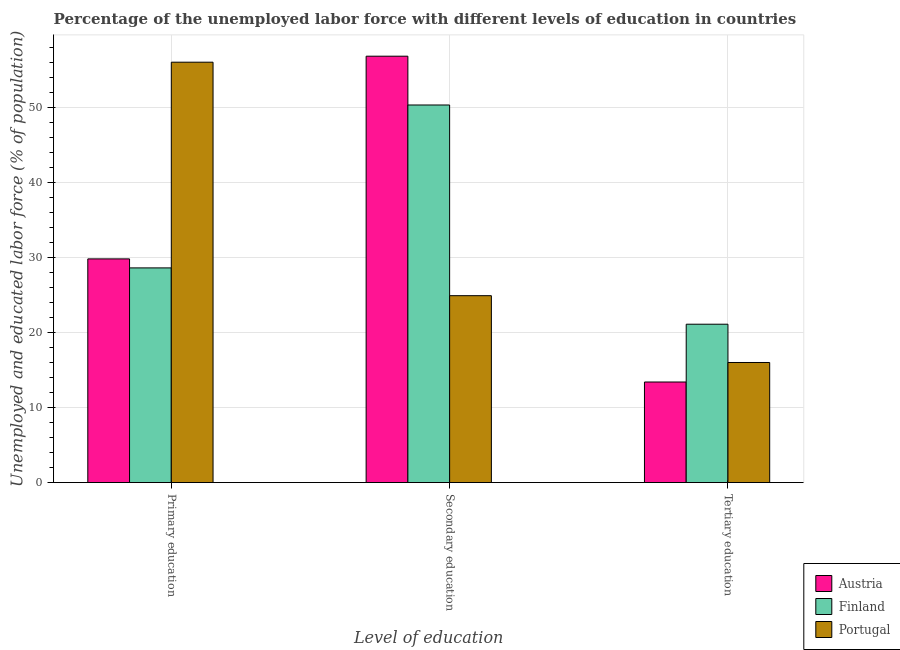How many different coloured bars are there?
Offer a terse response. 3. Are the number of bars on each tick of the X-axis equal?
Give a very brief answer. Yes. What is the label of the 1st group of bars from the left?
Your response must be concise. Primary education. What is the percentage of labor force who received secondary education in Austria?
Your answer should be very brief. 56.8. Across all countries, what is the maximum percentage of labor force who received tertiary education?
Provide a short and direct response. 21.1. Across all countries, what is the minimum percentage of labor force who received secondary education?
Your answer should be compact. 24.9. In which country was the percentage of labor force who received tertiary education maximum?
Make the answer very short. Finland. What is the total percentage of labor force who received secondary education in the graph?
Provide a succinct answer. 132. What is the difference between the percentage of labor force who received tertiary education in Finland and that in Portugal?
Your response must be concise. 5.1. What is the difference between the percentage of labor force who received secondary education in Finland and the percentage of labor force who received tertiary education in Austria?
Provide a short and direct response. 36.9. What is the average percentage of labor force who received primary education per country?
Your answer should be very brief. 38.13. What is the difference between the percentage of labor force who received secondary education and percentage of labor force who received primary education in Austria?
Keep it short and to the point. 27. In how many countries, is the percentage of labor force who received tertiary education greater than 28 %?
Your response must be concise. 0. What is the ratio of the percentage of labor force who received secondary education in Portugal to that in Austria?
Offer a terse response. 0.44. Is the difference between the percentage of labor force who received primary education in Finland and Portugal greater than the difference between the percentage of labor force who received secondary education in Finland and Portugal?
Provide a short and direct response. No. What is the difference between the highest and the lowest percentage of labor force who received tertiary education?
Provide a succinct answer. 7.7. In how many countries, is the percentage of labor force who received tertiary education greater than the average percentage of labor force who received tertiary education taken over all countries?
Give a very brief answer. 1. Is the sum of the percentage of labor force who received tertiary education in Portugal and Austria greater than the maximum percentage of labor force who received primary education across all countries?
Give a very brief answer. No. What does the 3rd bar from the left in Primary education represents?
Offer a terse response. Portugal. What does the 1st bar from the right in Primary education represents?
Offer a very short reply. Portugal. How many countries are there in the graph?
Your answer should be compact. 3. Does the graph contain any zero values?
Offer a very short reply. No. Where does the legend appear in the graph?
Make the answer very short. Bottom right. What is the title of the graph?
Make the answer very short. Percentage of the unemployed labor force with different levels of education in countries. Does "Vietnam" appear as one of the legend labels in the graph?
Ensure brevity in your answer.  No. What is the label or title of the X-axis?
Your response must be concise. Level of education. What is the label or title of the Y-axis?
Your answer should be compact. Unemployed and educated labor force (% of population). What is the Unemployed and educated labor force (% of population) of Austria in Primary education?
Offer a terse response. 29.8. What is the Unemployed and educated labor force (% of population) in Finland in Primary education?
Offer a very short reply. 28.6. What is the Unemployed and educated labor force (% of population) in Portugal in Primary education?
Your answer should be compact. 56. What is the Unemployed and educated labor force (% of population) in Austria in Secondary education?
Make the answer very short. 56.8. What is the Unemployed and educated labor force (% of population) in Finland in Secondary education?
Provide a short and direct response. 50.3. What is the Unemployed and educated labor force (% of population) in Portugal in Secondary education?
Offer a very short reply. 24.9. What is the Unemployed and educated labor force (% of population) in Austria in Tertiary education?
Offer a very short reply. 13.4. What is the Unemployed and educated labor force (% of population) of Finland in Tertiary education?
Provide a succinct answer. 21.1. What is the Unemployed and educated labor force (% of population) of Portugal in Tertiary education?
Provide a short and direct response. 16. Across all Level of education, what is the maximum Unemployed and educated labor force (% of population) in Austria?
Your answer should be very brief. 56.8. Across all Level of education, what is the maximum Unemployed and educated labor force (% of population) of Finland?
Provide a succinct answer. 50.3. Across all Level of education, what is the minimum Unemployed and educated labor force (% of population) in Austria?
Your answer should be very brief. 13.4. Across all Level of education, what is the minimum Unemployed and educated labor force (% of population) in Finland?
Offer a very short reply. 21.1. Across all Level of education, what is the minimum Unemployed and educated labor force (% of population) of Portugal?
Your response must be concise. 16. What is the total Unemployed and educated labor force (% of population) in Finland in the graph?
Ensure brevity in your answer.  100. What is the total Unemployed and educated labor force (% of population) in Portugal in the graph?
Make the answer very short. 96.9. What is the difference between the Unemployed and educated labor force (% of population) of Finland in Primary education and that in Secondary education?
Ensure brevity in your answer.  -21.7. What is the difference between the Unemployed and educated labor force (% of population) of Portugal in Primary education and that in Secondary education?
Your answer should be very brief. 31.1. What is the difference between the Unemployed and educated labor force (% of population) of Finland in Primary education and that in Tertiary education?
Keep it short and to the point. 7.5. What is the difference between the Unemployed and educated labor force (% of population) of Portugal in Primary education and that in Tertiary education?
Your answer should be very brief. 40. What is the difference between the Unemployed and educated labor force (% of population) of Austria in Secondary education and that in Tertiary education?
Your response must be concise. 43.4. What is the difference between the Unemployed and educated labor force (% of population) in Finland in Secondary education and that in Tertiary education?
Provide a succinct answer. 29.2. What is the difference between the Unemployed and educated labor force (% of population) in Austria in Primary education and the Unemployed and educated labor force (% of population) in Finland in Secondary education?
Provide a succinct answer. -20.5. What is the difference between the Unemployed and educated labor force (% of population) in Austria in Primary education and the Unemployed and educated labor force (% of population) in Portugal in Secondary education?
Make the answer very short. 4.9. What is the difference between the Unemployed and educated labor force (% of population) of Finland in Primary education and the Unemployed and educated labor force (% of population) of Portugal in Tertiary education?
Offer a very short reply. 12.6. What is the difference between the Unemployed and educated labor force (% of population) of Austria in Secondary education and the Unemployed and educated labor force (% of population) of Finland in Tertiary education?
Offer a terse response. 35.7. What is the difference between the Unemployed and educated labor force (% of population) of Austria in Secondary education and the Unemployed and educated labor force (% of population) of Portugal in Tertiary education?
Give a very brief answer. 40.8. What is the difference between the Unemployed and educated labor force (% of population) in Finland in Secondary education and the Unemployed and educated labor force (% of population) in Portugal in Tertiary education?
Keep it short and to the point. 34.3. What is the average Unemployed and educated labor force (% of population) in Austria per Level of education?
Make the answer very short. 33.33. What is the average Unemployed and educated labor force (% of population) of Finland per Level of education?
Provide a succinct answer. 33.33. What is the average Unemployed and educated labor force (% of population) of Portugal per Level of education?
Keep it short and to the point. 32.3. What is the difference between the Unemployed and educated labor force (% of population) of Austria and Unemployed and educated labor force (% of population) of Portugal in Primary education?
Keep it short and to the point. -26.2. What is the difference between the Unemployed and educated labor force (% of population) in Finland and Unemployed and educated labor force (% of population) in Portugal in Primary education?
Your answer should be compact. -27.4. What is the difference between the Unemployed and educated labor force (% of population) in Austria and Unemployed and educated labor force (% of population) in Portugal in Secondary education?
Ensure brevity in your answer.  31.9. What is the difference between the Unemployed and educated labor force (% of population) in Finland and Unemployed and educated labor force (% of population) in Portugal in Secondary education?
Provide a short and direct response. 25.4. What is the difference between the Unemployed and educated labor force (% of population) of Austria and Unemployed and educated labor force (% of population) of Finland in Tertiary education?
Make the answer very short. -7.7. What is the difference between the Unemployed and educated labor force (% of population) in Austria and Unemployed and educated labor force (% of population) in Portugal in Tertiary education?
Ensure brevity in your answer.  -2.6. What is the difference between the Unemployed and educated labor force (% of population) in Finland and Unemployed and educated labor force (% of population) in Portugal in Tertiary education?
Ensure brevity in your answer.  5.1. What is the ratio of the Unemployed and educated labor force (% of population) in Austria in Primary education to that in Secondary education?
Your answer should be very brief. 0.52. What is the ratio of the Unemployed and educated labor force (% of population) in Finland in Primary education to that in Secondary education?
Give a very brief answer. 0.57. What is the ratio of the Unemployed and educated labor force (% of population) in Portugal in Primary education to that in Secondary education?
Provide a succinct answer. 2.25. What is the ratio of the Unemployed and educated labor force (% of population) in Austria in Primary education to that in Tertiary education?
Offer a terse response. 2.22. What is the ratio of the Unemployed and educated labor force (% of population) in Finland in Primary education to that in Tertiary education?
Provide a short and direct response. 1.36. What is the ratio of the Unemployed and educated labor force (% of population) in Austria in Secondary education to that in Tertiary education?
Provide a short and direct response. 4.24. What is the ratio of the Unemployed and educated labor force (% of population) of Finland in Secondary education to that in Tertiary education?
Keep it short and to the point. 2.38. What is the ratio of the Unemployed and educated labor force (% of population) in Portugal in Secondary education to that in Tertiary education?
Your answer should be compact. 1.56. What is the difference between the highest and the second highest Unemployed and educated labor force (% of population) of Austria?
Keep it short and to the point. 27. What is the difference between the highest and the second highest Unemployed and educated labor force (% of population) of Finland?
Provide a short and direct response. 21.7. What is the difference between the highest and the second highest Unemployed and educated labor force (% of population) of Portugal?
Provide a succinct answer. 31.1. What is the difference between the highest and the lowest Unemployed and educated labor force (% of population) of Austria?
Make the answer very short. 43.4. What is the difference between the highest and the lowest Unemployed and educated labor force (% of population) of Finland?
Provide a succinct answer. 29.2. What is the difference between the highest and the lowest Unemployed and educated labor force (% of population) in Portugal?
Offer a very short reply. 40. 